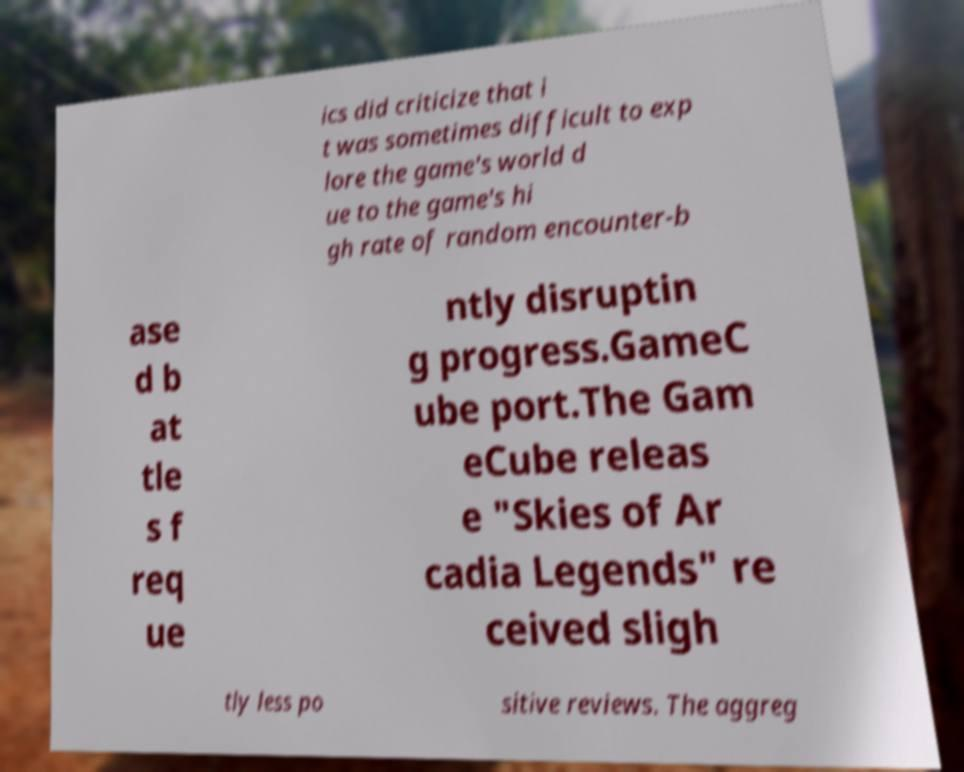What messages or text are displayed in this image? I need them in a readable, typed format. ics did criticize that i t was sometimes difficult to exp lore the game's world d ue to the game's hi gh rate of random encounter-b ase d b at tle s f req ue ntly disruptin g progress.GameC ube port.The Gam eCube releas e "Skies of Ar cadia Legends" re ceived sligh tly less po sitive reviews. The aggreg 